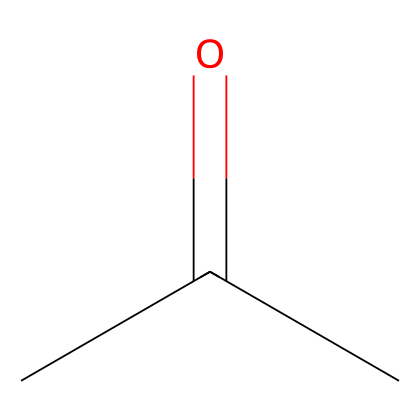What is the molecular formula of this compound? The molecular formula can be determined by counting the number of carbon (C), hydrogen (H), and oxygen (O) atoms from the structure. There are 3 carbon atoms, 6 hydrogen atoms, and 1 oxygen atom in the chemical structure of acetone (CC(=O)C). Thus, the molecular formula is C3H6O.
Answer: C3H6O How many carbon atoms are there in acetone? By analyzing the SMILES representation, we see "CC" indicating two carbon atoms and there’s another carbon involved in the carbonyl group "C(=O)", totaling three carbon atoms.
Answer: 3 What type of functional group is present in acetone? In the chemical structure CC(=O)C, the "C(=O)" part indicates a carbonyl group, which is characteristic of ketones. Ketones are defined by the presence of a carbonyl group attached to two carbon atoms.
Answer: carbonyl What is the hybridization of the carbonyl carbon in acetone? The carbon in the carbonyl group, indicated by "C(=O)", is bonded to one oxygen and two other carbons, which suggests it has a trigonal planar geometry. Trigonal planar corresponds to sp2 hybridization.
Answer: sp2 What is the characteristic odor of acetone? Acetone is known for its distinct odor which can be described as sweet or fruity. This is due to its chemical structure, which also allows it to evaporate quickly, contributing to its scent.
Answer: sweet How many hydrogen atoms are attached to the central carbon of acetone? In the structure, the central carbon atom connected to the carbonyl group has three additional hydrogen atoms attached to it, making it CH3 (methyl group).
Answer: 3 Is acetone polar or nonpolar? The presence of a polar carbonyl group contributes to acetone being polar overall, although it also has nonpolar methyl groups. This results in a molecule that has polar characteristics.
Answer: polar 